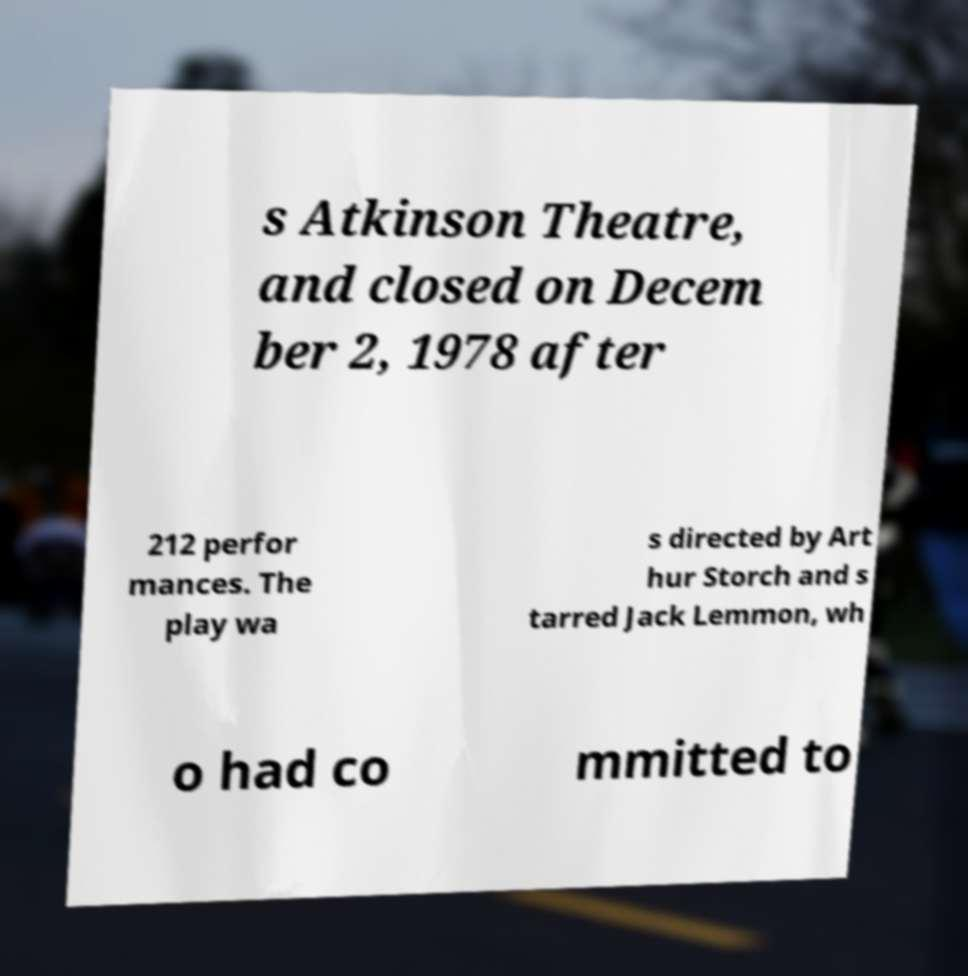There's text embedded in this image that I need extracted. Can you transcribe it verbatim? s Atkinson Theatre, and closed on Decem ber 2, 1978 after 212 perfor mances. The play wa s directed by Art hur Storch and s tarred Jack Lemmon, wh o had co mmitted to 